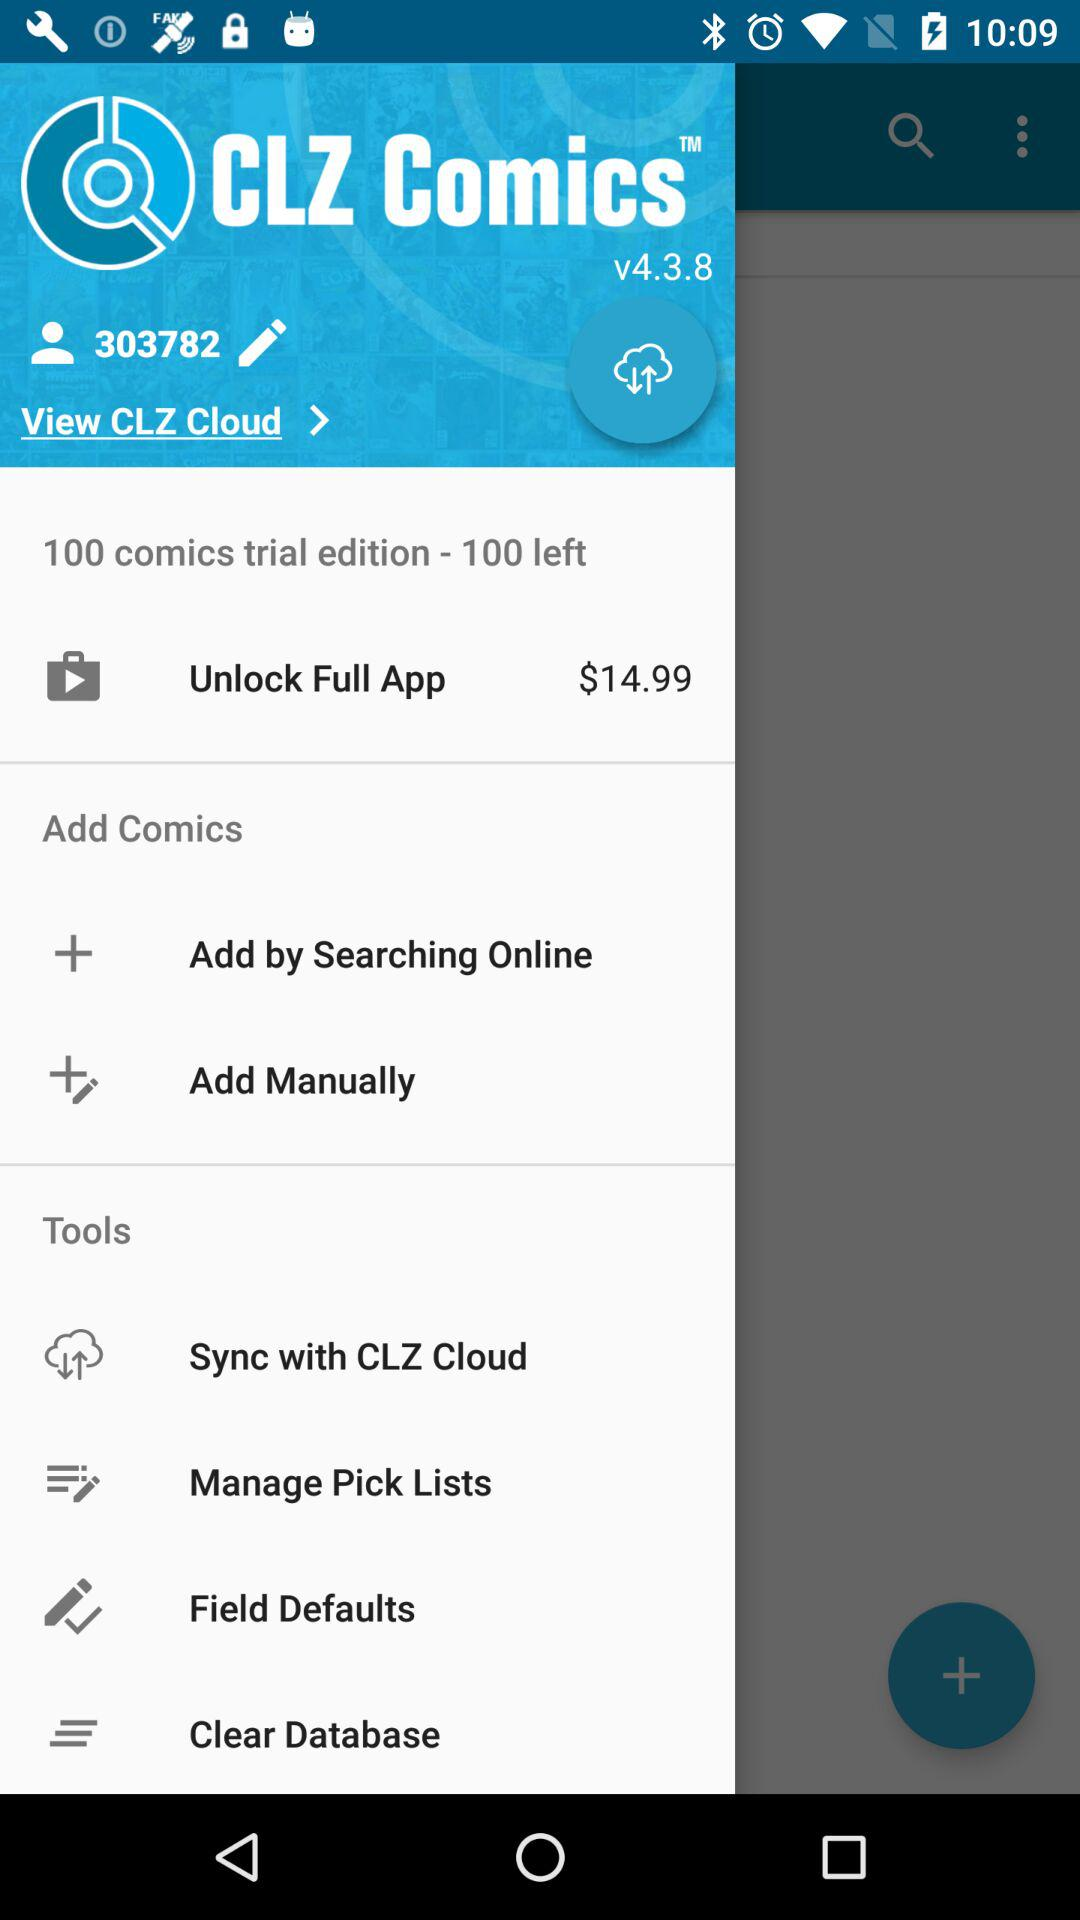What is the version of "CLZ Comics"? The version of "CLZ Comics" is v4.3.8. 